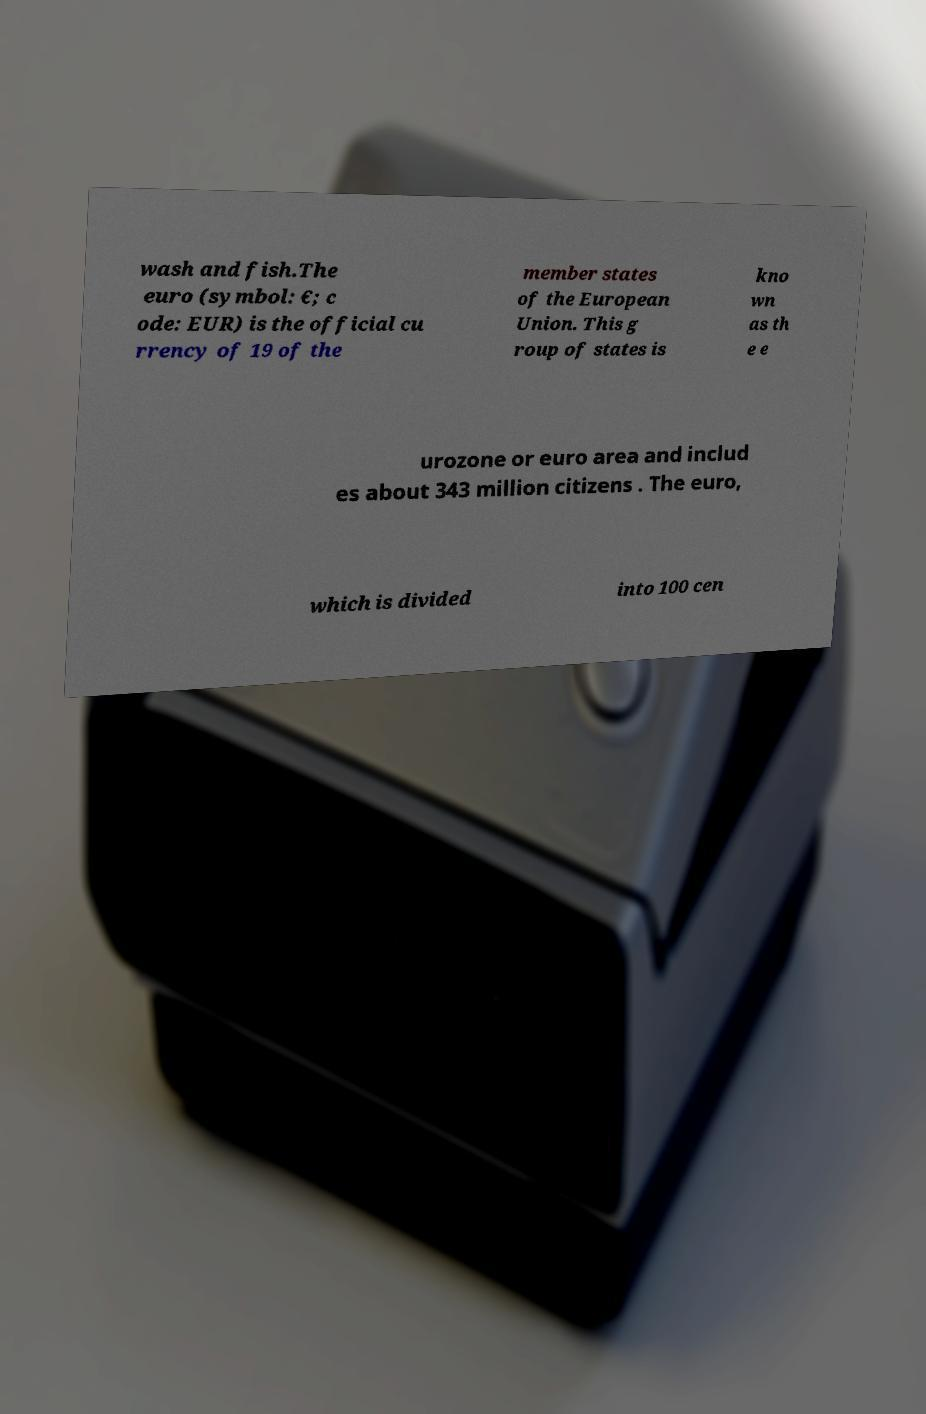Could you extract and type out the text from this image? wash and fish.The euro (symbol: €; c ode: EUR) is the official cu rrency of 19 of the member states of the European Union. This g roup of states is kno wn as th e e urozone or euro area and includ es about 343 million citizens . The euro, which is divided into 100 cen 